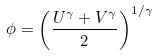<formula> <loc_0><loc_0><loc_500><loc_500>\phi = \left ( \frac { U ^ { \gamma } + V ^ { \gamma } } { 2 } \right ) ^ { 1 / \gamma }</formula> 